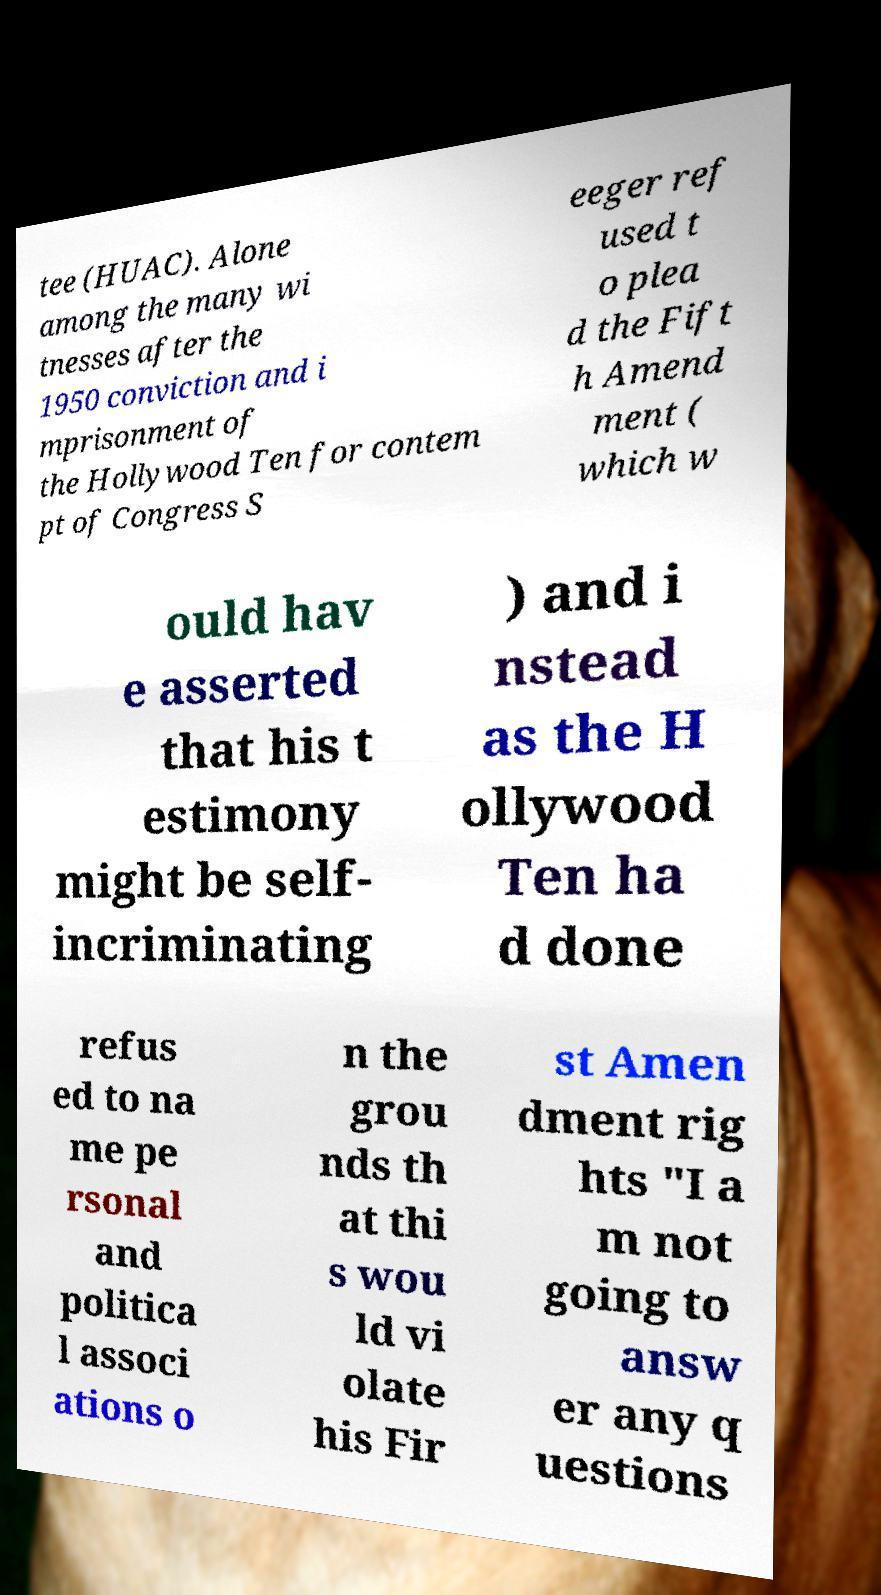Could you extract and type out the text from this image? tee (HUAC). Alone among the many wi tnesses after the 1950 conviction and i mprisonment of the Hollywood Ten for contem pt of Congress S eeger ref used t o plea d the Fift h Amend ment ( which w ould hav e asserted that his t estimony might be self- incriminating ) and i nstead as the H ollywood Ten ha d done refus ed to na me pe rsonal and politica l associ ations o n the grou nds th at thi s wou ld vi olate his Fir st Amen dment rig hts "I a m not going to answ er any q uestions 